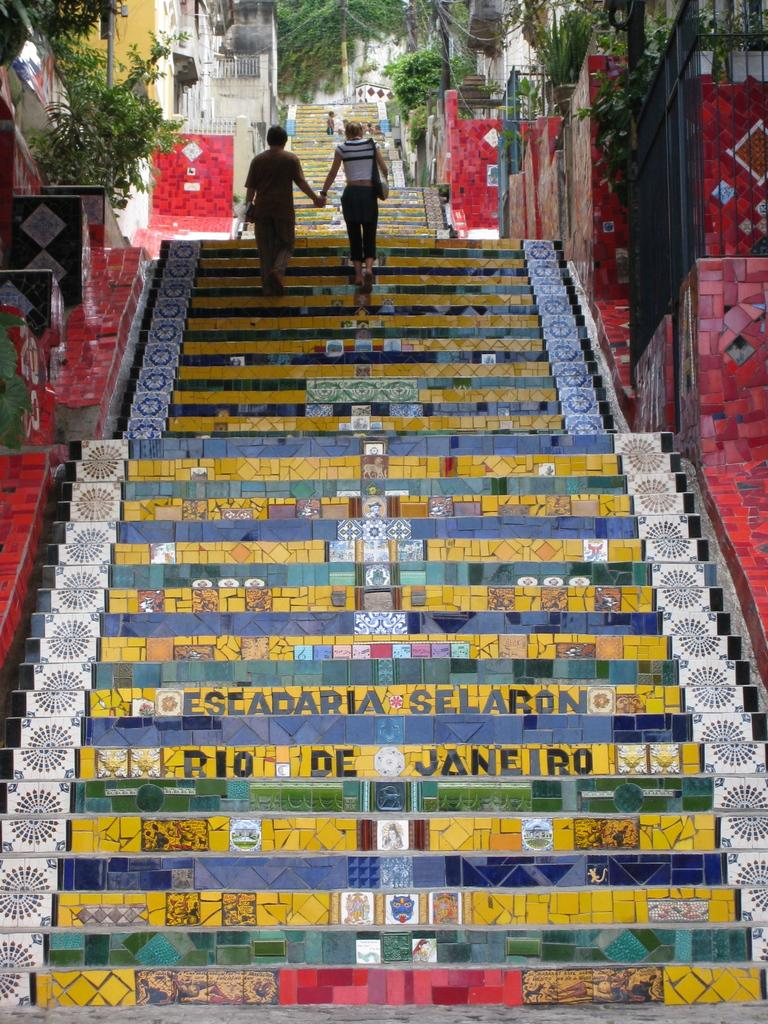What can be seen in the image that leads to a higher or lower level? There are steps in the image that lead to a higher or lower level. What is the color of the steps in the image? The steps are yellow in color. What type of vegetation can be seen in the background of the image? There are plants and trees in the background of the image. What type of structures can be seen in the background of the image? There are buildings in the background of the image. Are there any people visible in the image? Yes, there are people on the steps in the background of the image. What type of humor can be seen on the wrist of the person on the steps in the image? There is no humor or wrist visible in the image; it only shows steps, plants, trees, buildings, and people. 